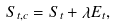<formula> <loc_0><loc_0><loc_500><loc_500>S _ { t , c } = S _ { t } + \lambda E _ { t } ,</formula> 